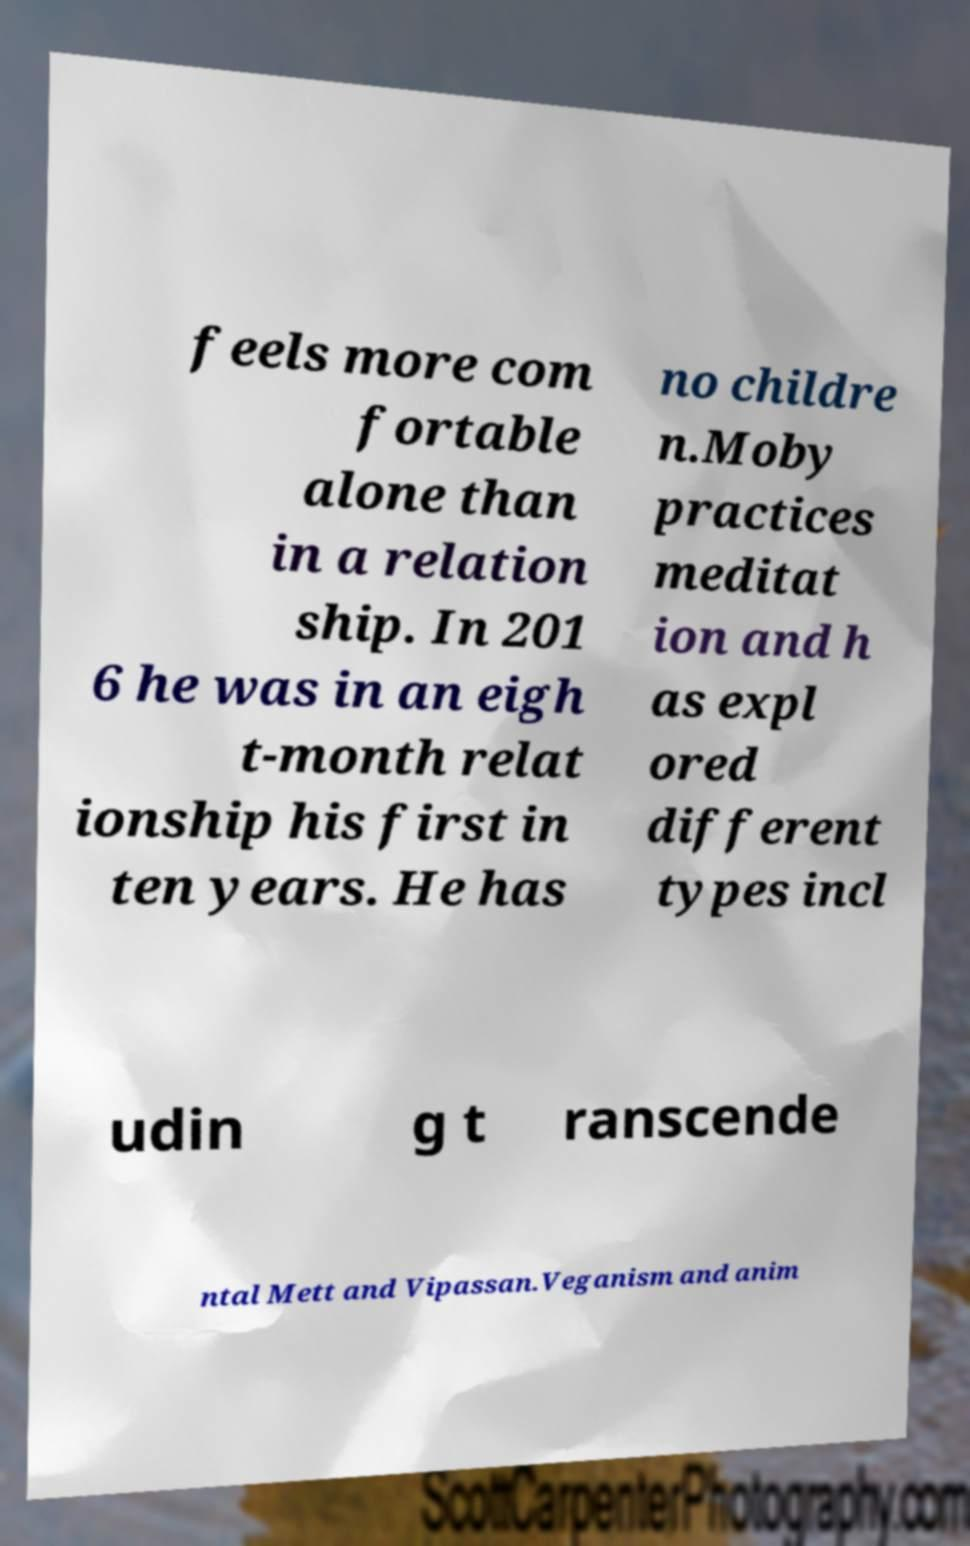I need the written content from this picture converted into text. Can you do that? feels more com fortable alone than in a relation ship. In 201 6 he was in an eigh t-month relat ionship his first in ten years. He has no childre n.Moby practices meditat ion and h as expl ored different types incl udin g t ranscende ntal Mett and Vipassan.Veganism and anim 